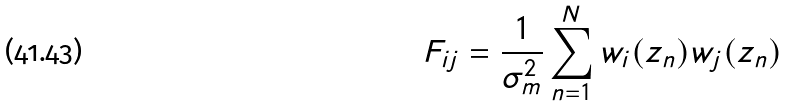<formula> <loc_0><loc_0><loc_500><loc_500>F _ { i j } = \frac { 1 } { \sigma _ { m } ^ { 2 } } \sum _ { n = 1 } ^ { N } w _ { i } ( z _ { n } ) w _ { j } ( z _ { n } )</formula> 